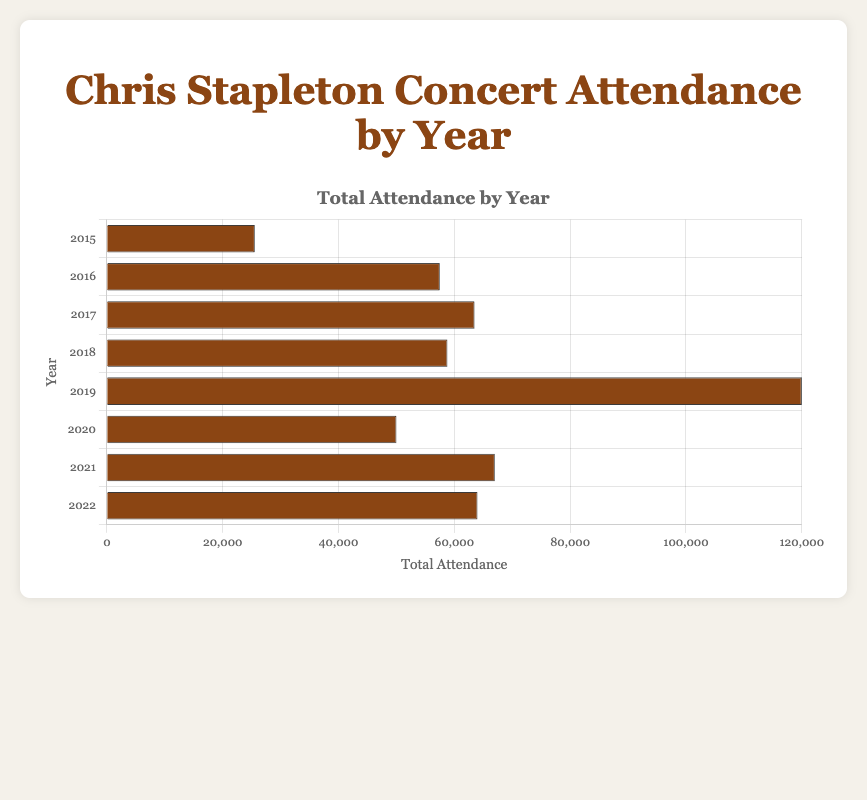What year had the highest total attendance? By observing the bar heights, the year 2019 has the longest bar, indicating the highest total attendance.
Answer: 2019 How did the attendance in 2019 compare to 2020? In 2019, the attendance was 120,000, which is much higher than the 50,000 in 2020.
Answer: 120,000 vs 50,000 What is the difference in total attendance between 2016 and 2017? The attendance in 2016 was 57,500, and in 2017 it was 63,500. The difference is 63,500 - 57,500 = 6,000.
Answer: 6,000 What is the average attendance from 2015 to 2022? Sum the total attendances for each year from 2015 to 2022 and divide by the number of years: (25,550 + 57,500 + 63,500 + 58,800 + 120,000 + 50,000 + 67,000 + 64,000) / 8 = 63,543.75
Answer: 63,543.75 Among all the years displayed, which year had the lowest total attendance? The bar for 2015 is the shortest, indicating the lowest total attendance.
Answer: 2015 What was the total attendance increase from 2018 to 2019? The attendance in 2018 was 58,800, and in 2019 it was 120,000. The increase is 120,000 - 58,800 = 61,200.
Answer: 61,200 How does the attendance of 2022 compare to 2017? The attendance in 2022 was 64,000, whereas in 2017, it was 63,500. The difference is 64,000 - 63,500 = 500.
Answer: 64,000 vs 63,500; 500 more in 2022 How many years had an attendance greater than 60,000? We need to count the years where the bar length corresponds to values greater than 60,000: 2017, 2019, 2021, 2022.
Answer: 4 What's the average attendance for the years 2015, 2016, and 2017? Sum the total attendances for 2015, 2016, and 2017 and divide by 3: (25,550 + 57,500 + 63,500) / 3 = 48,850.
Answer: 48,850 Which years had an attendance close to 50,000? Observing the bars, 2020 (50,000) exactly, no other year is close.
Answer: 2020 